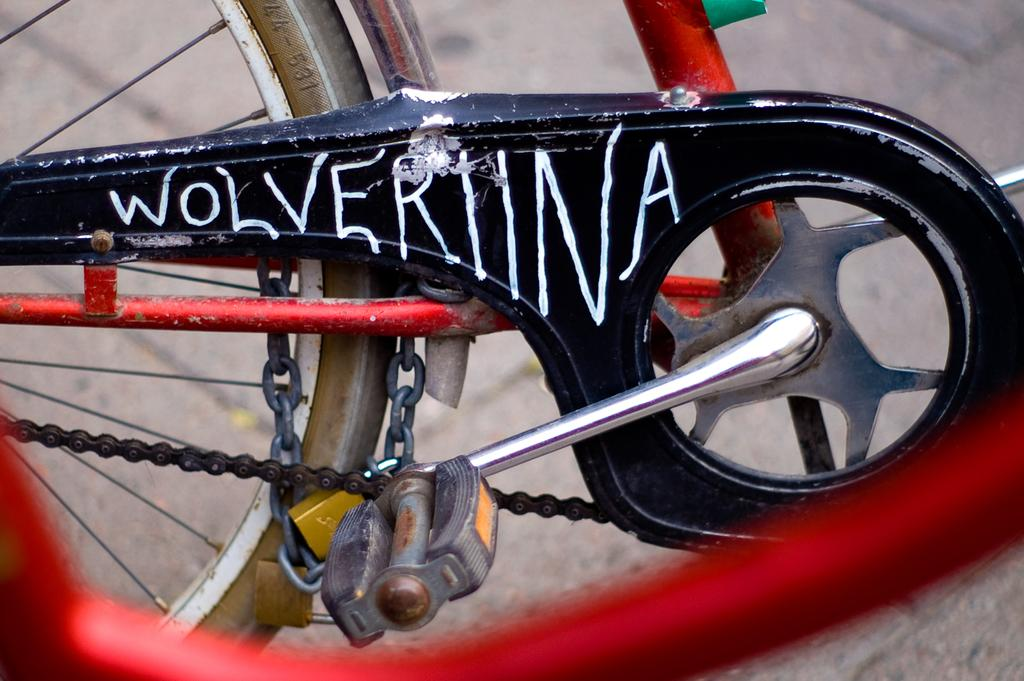What is the main object in the image? There is a bicycle in the image. What colors can be seen on the bicycle? The bicycle is red and black in color. What feature is present on the bicycle to secure it? There is a lock on the bicycle. What part of the bicycle is used for propulsion? The bicycle has pedals for propulsion. How many wheels are on the bicycle? There is a wheel on the bicycle. How does the daughter interact with the bicycle in the image? There is no daughter present in the image. 